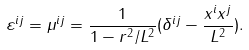<formula> <loc_0><loc_0><loc_500><loc_500>\varepsilon ^ { i j } = \mu ^ { i j } = \frac { 1 } { 1 - r ^ { 2 } / L ^ { 2 } } ( \delta ^ { i j } - \frac { x ^ { i } x ^ { j } } { L ^ { 2 } } ) .</formula> 